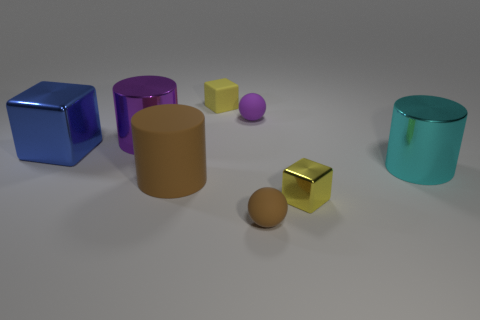Is there a blue cylinder made of the same material as the brown sphere?
Give a very brief answer. No. What is the material of the brown thing that is the same size as the yellow metallic object?
Your answer should be very brief. Rubber. Are there fewer yellow rubber objects that are on the left side of the blue metal block than yellow matte blocks behind the purple metal object?
Your answer should be compact. Yes. The thing that is behind the large shiny cube and in front of the small purple rubber object has what shape?
Offer a very short reply. Cylinder. What number of brown things are the same shape as the small yellow metallic thing?
Ensure brevity in your answer.  0. What is the size of the block that is the same material as the large blue thing?
Provide a short and direct response. Small. Are there more tiny green metal balls than tiny objects?
Offer a terse response. No. The sphere in front of the large purple metallic cylinder is what color?
Offer a very short reply. Brown. How big is the block that is to the right of the large purple cylinder and on the left side of the yellow metal thing?
Make the answer very short. Small. How many gray metal balls have the same size as the purple rubber object?
Keep it short and to the point. 0. 